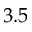<formula> <loc_0><loc_0><loc_500><loc_500>3 . 5</formula> 